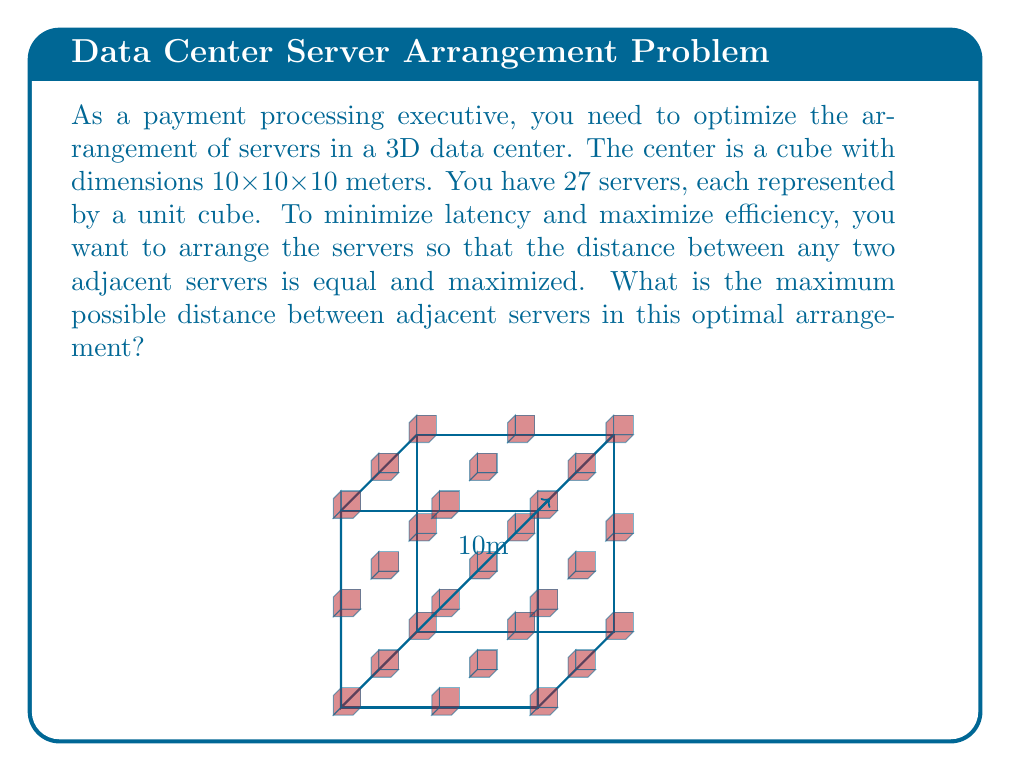Help me with this question. Let's approach this step-by-step:

1) First, we need to recognize that the optimal arrangement for 27 servers in a cube is a 3x3x3 grid. This ensures equal spacing between adjacent servers in all directions.

2) In this arrangement, there will be 2 equal spaces between servers in each dimension of the cube.

3) Let's denote the distance between adjacent servers as $d$. Then, in each dimension of the 10m cube, we have:

   $$2d + 3 = 10$$

   Where 3 represents the total width of the three servers in each row/column/stack.

4) Solving for $d$:

   $$2d = 7$$
   $$d = \frac{7}{2} = 3.5$$

5) To verify, we can check:
   $$3.5 + 1 + 3.5 + 1 + 3.5 = 10$$

   This confirms that 3 servers with 2 spaces of 3.5m each fit perfectly in the 10m dimension.

6) The distance between adjacent servers is the same in all three dimensions due to the cubic arrangement.

Therefore, the maximum possible distance between adjacent servers in this optimal arrangement is 3.5 meters.
Answer: 3.5 meters 